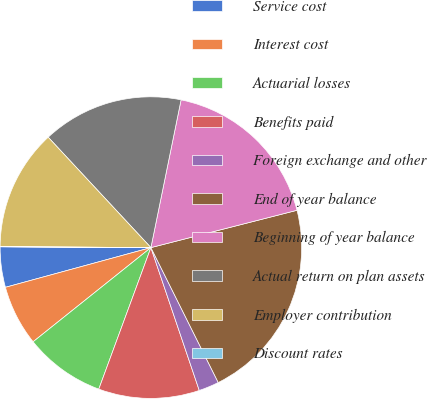Convert chart. <chart><loc_0><loc_0><loc_500><loc_500><pie_chart><fcel>Service cost<fcel>Interest cost<fcel>Actuarial losses<fcel>Benefits paid<fcel>Foreign exchange and other<fcel>End of year balance<fcel>Beginning of year balance<fcel>Actual return on plan assets<fcel>Employer contribution<fcel>Discount rates<nl><fcel>4.33%<fcel>6.49%<fcel>8.65%<fcel>10.81%<fcel>2.17%<fcel>21.61%<fcel>17.81%<fcel>15.13%<fcel>12.97%<fcel>0.01%<nl></chart> 